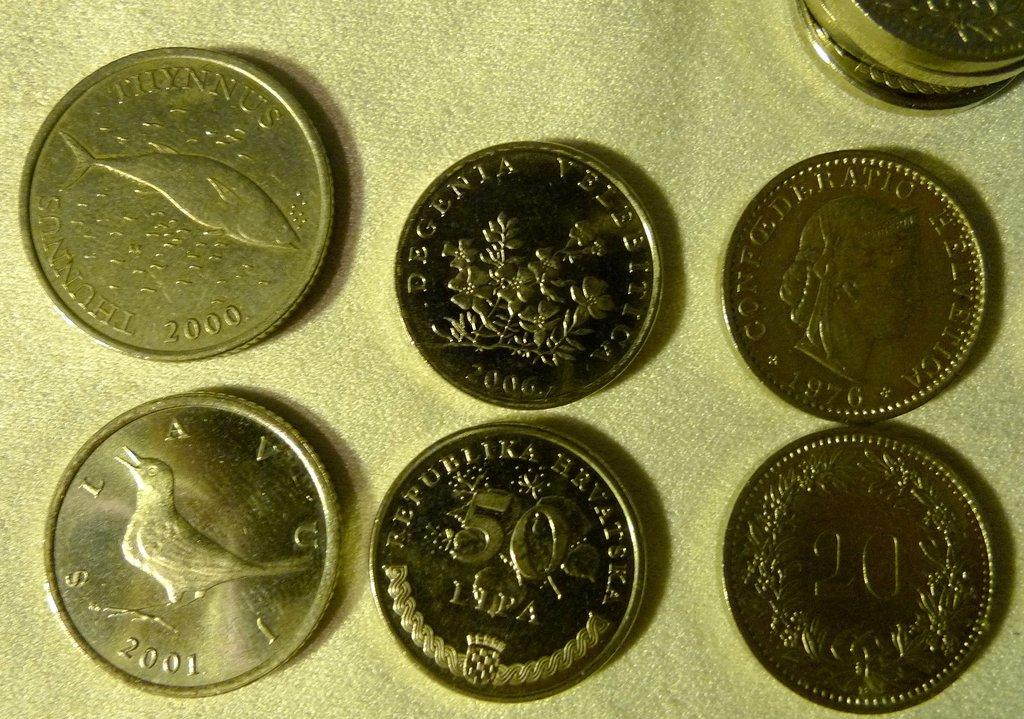<image>
Write a terse but informative summary of the picture. Coins in different denominations, including one with a bird minted in 2001 are lined up. 